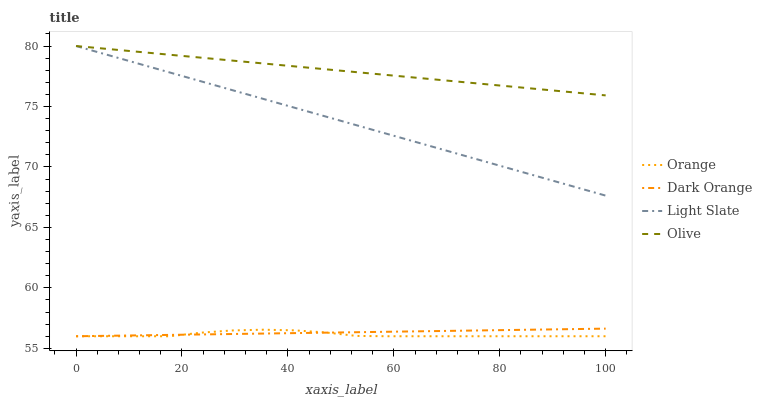Does Dark Orange have the minimum area under the curve?
Answer yes or no. No. Does Dark Orange have the maximum area under the curve?
Answer yes or no. No. Is Dark Orange the smoothest?
Answer yes or no. No. Is Dark Orange the roughest?
Answer yes or no. No. Does Light Slate have the lowest value?
Answer yes or no. No. Does Dark Orange have the highest value?
Answer yes or no. No. Is Orange less than Olive?
Answer yes or no. Yes. Is Light Slate greater than Orange?
Answer yes or no. Yes. Does Orange intersect Olive?
Answer yes or no. No. 